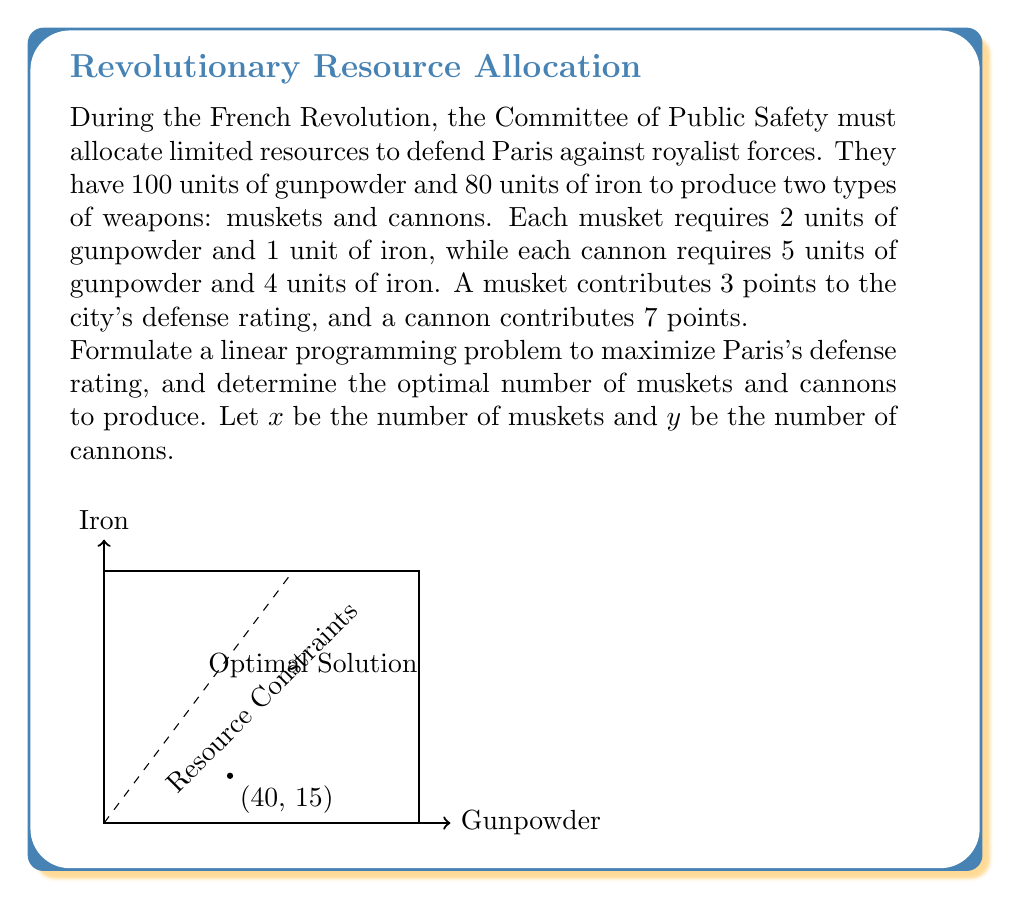Teach me how to tackle this problem. Let's approach this step-by-step:

1) First, we need to formulate the objective function. We want to maximize the defense rating:
   $$ \text{Maximize } Z = 3x + 7y $$

2) Now, let's define the constraints:
   a) Gunpowder constraint: $2x + 5y \leq 100$
   b) Iron constraint: $x + 4y \leq 80$
   c) Non-negativity constraints: $x \geq 0, y \geq 0$

3) The complete linear programming problem is:
   $$ \begin{align*}
   \text{Maximize } & Z = 3x + 7y \\
   \text{subject to: } & 2x + 5y \leq 100 \\
   & x + 4y \leq 80 \\
   & x, y \geq 0
   \end{align*} $$

4) To solve this, we can use the graphical method or the simplex algorithm. Let's use the graphical method:

5) Plot the constraints:
   - $2x + 5y = 100$ intersects at (50,0) and (0,20)
   - $x + 4y = 80$ intersects at (80,0) and (0,20)

6) The feasible region is the area bounded by these lines and the axes.

7) The optimal solution will be at one of the corner points. We need to check:
   (0,0), (50,0), (80,0), (0,20), and the intersection of the two constraint lines.

8) The intersection point can be found by solving:
   $2x + 5y = 100$
   $x + 4y = 80$
   Solving these gives $x = 40, y = 15$

9) Evaluating Z at each point:
   (0,0): Z = 0
   (50,0): Z = 150
   (80,0): Z = 240
   (0,20): Z = 140
   (40,15): Z = 3(40) + 7(15) = 225

10) The maximum value of Z occurs at (40,15).
Answer: Produce 40 muskets and 15 cannons. 